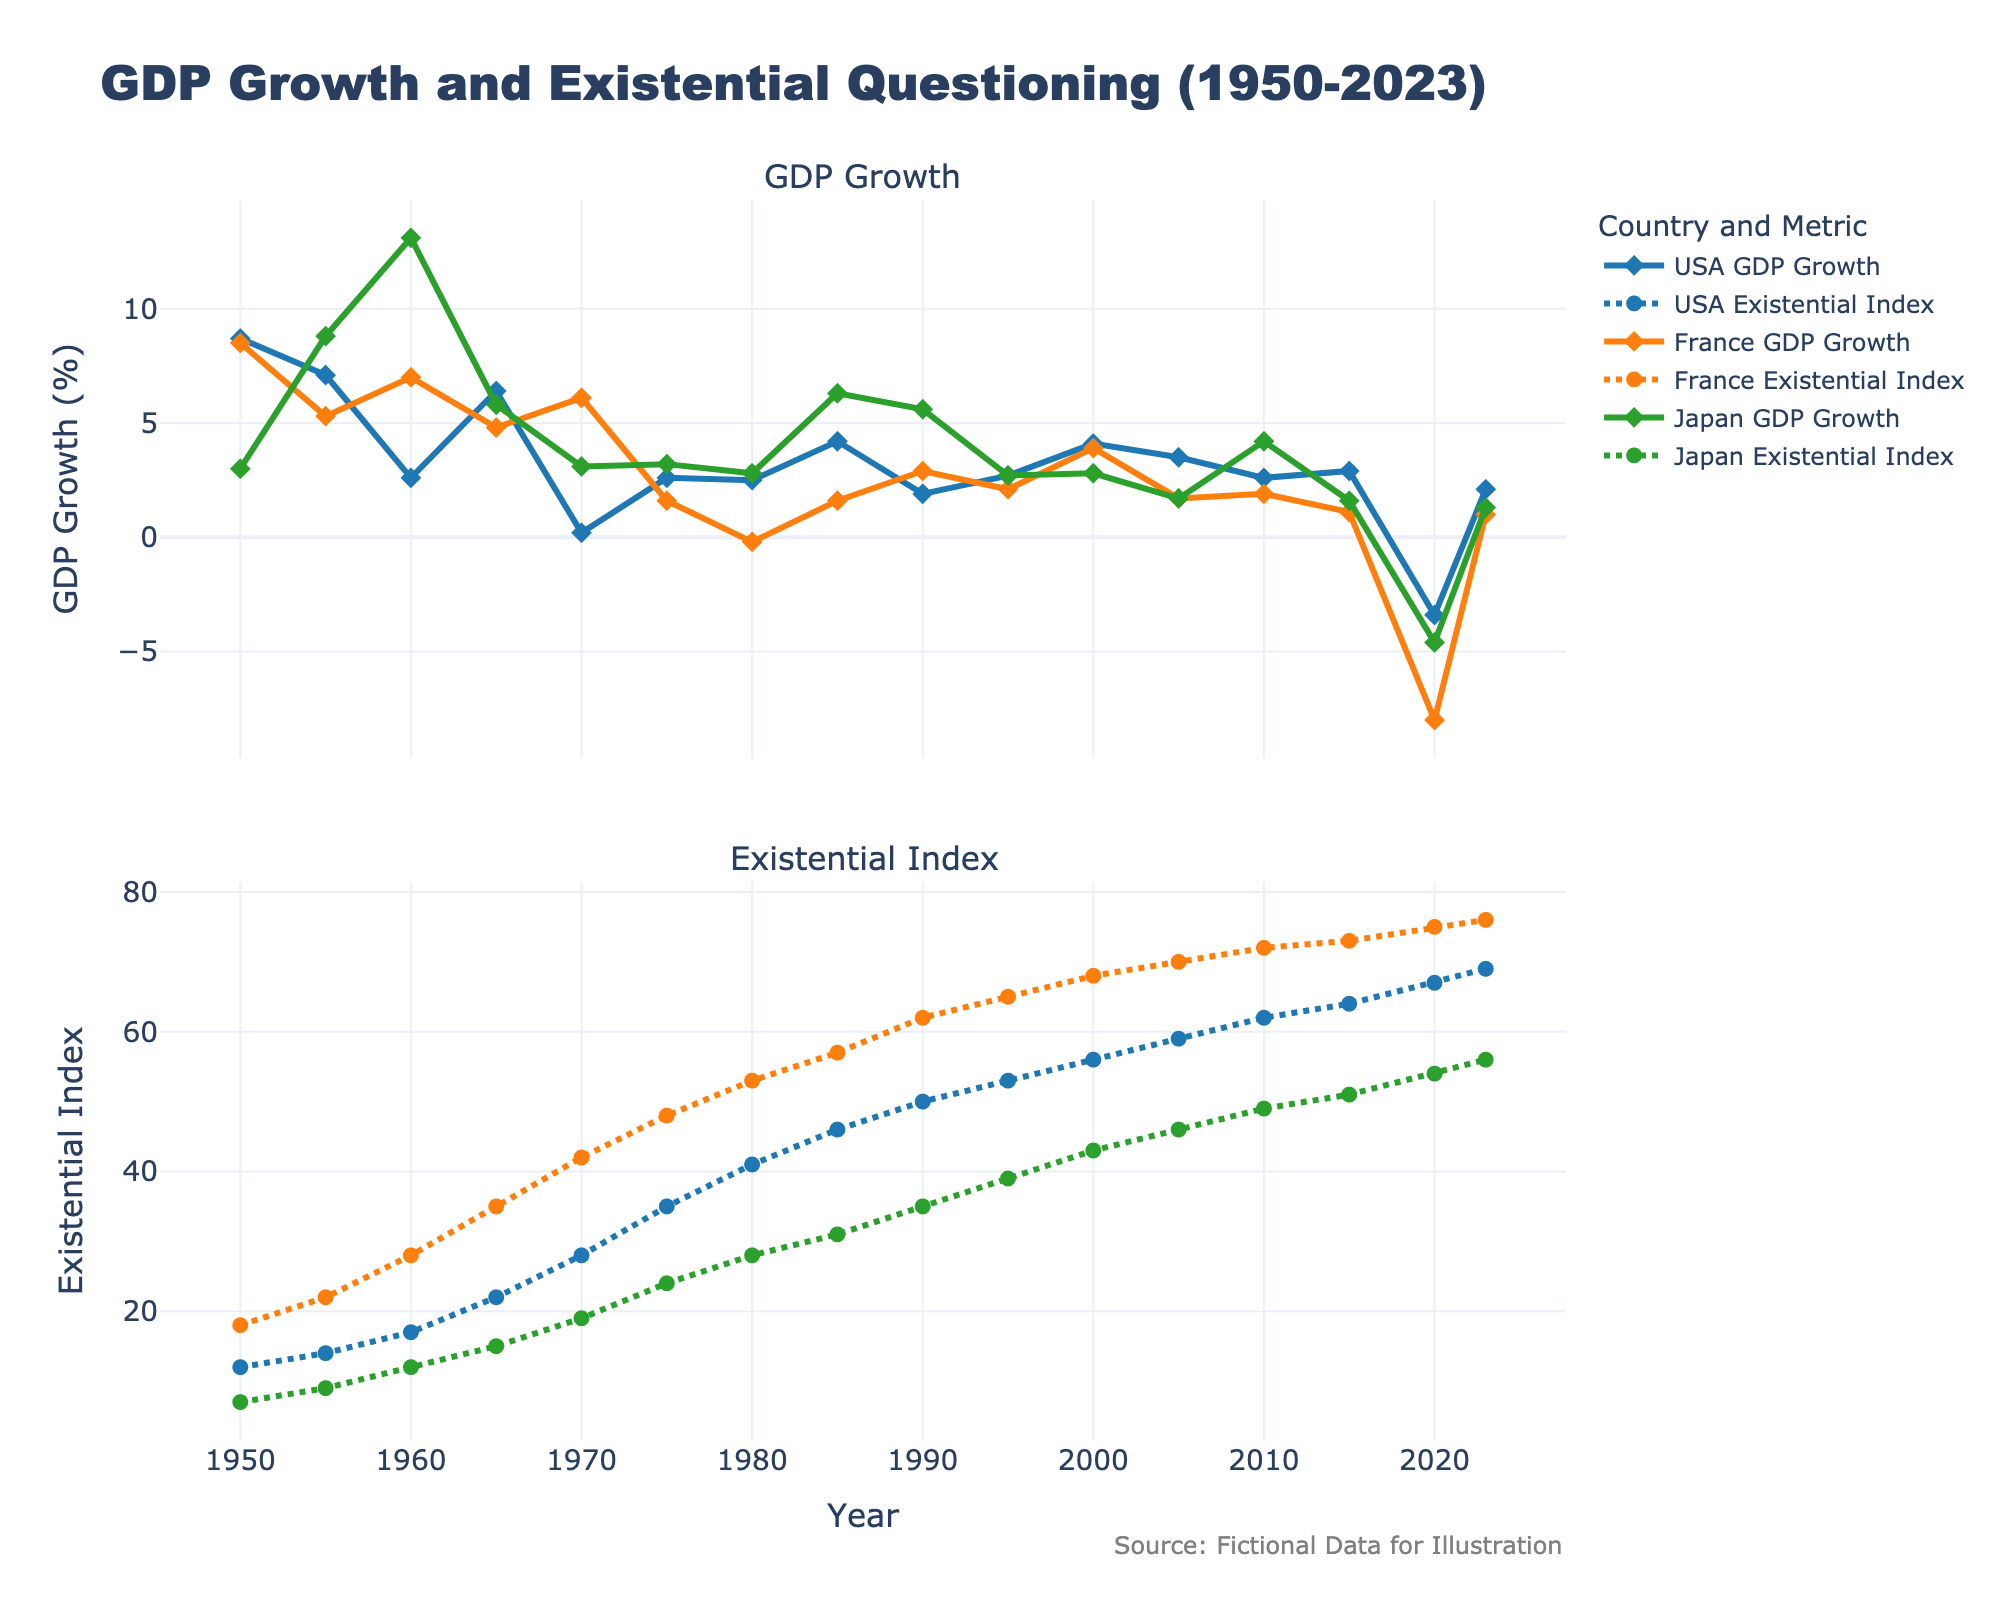What year did France experience the largest drop in GDP growth? To determine when France experienced the largest drop in GDP growth, examine the GDP growth data line for France. Observe the largest downward movement. From 2015 to 2020, the GDP growth in France fell from 1.1% to -8.0%.
Answer: 2020 Compare the existential index of Japan and the USA in 2023. Which country has a higher value? Look at the existential index data for Japan and the USA in 2023. The USA's existential index is 69, and Japan's is 56.
Answer: USA What's the difference in GDP growth between Japan and the USA in 1960? Observe the GDP growth for Japan and the USA in 1960. The USA had 2.6% growth and Japan had 13.1%. The difference is 13.1% - 2.6% = 10.5%.
Answer: 10.5% During which year did the USA have the highest existential index? To find the year when the USA had the highest existential index, scan the data for the USA’s existential index values. The highest index value for the USA is 69 which occurred in 2023.
Answer: 2023 Is there a general trend between GDP growth and existential questions in France? To identify a general trend, compare the GDP growth and existential index lines for France from 1950 to 2023. As GDP growth decreases, the existential index increases, suggesting a negative correlation.
Answer: Negative correlation What are the average GDP growth rates for the USA and Japan between 1980 and 2000? Identify the GDP growth rates for the USA and Japan from 1980 to 2000, and calculate their averages. USA rates: 2.5%, 4.2%, 1.9%, 2.7%, 4.1%. Japan rates: 2.8%, 6.3%, 5.6%, 2.7%, 2.8%. USA average: (2.5% + 4.2% + 1.9% + 2.7% + 4.1%) / 5 = 3.08%. Japan average: (2.8% + 6.3% + 5.6% + 2.7% + 2.8%) / 5 = 4.04%.
Answer: USA: 3.08%, Japan: 4.04% What do the dotted lines represent in the charts? In the visual representation, dotted lines are used to distinguish a particular data attribute. Looking at the legend, the dotted lines represent the existential index for each country.
Answer: Existential Index Compare the GDP growth trends for the USA and Japan from 1990 to 2010. Which country had more stable growth? Examine the GDP growth lines for the USA and Japan between 1990 and 2010. The USA shows slight fluctuations with values around 1.9-4.2%, while Japan has more variability, especially with drops and increases between 1990-2010. The USA appears more stable.
Answer: USA What was the change in France's existential index between 1955 and 1975? Check the existential index for France in 1955 and 1975. The values are 22 in 1955 and 48 in 1975. The change is 48 - 22 = 26.
Answer: 26 Which country had the highest GDP growth in 1955 and what was the existential index for that country at the same time? Identify the GDP growth rates for all countries in 1955. Japan had the highest GDP growth at 8.8%. The existential index for Japan in 1955 was 9.
Answer: Japan, 9 